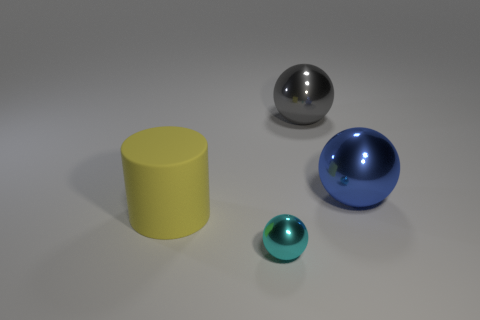Subtract all large balls. How many balls are left? 1 Add 2 large red metal balls. How many objects exist? 6 Subtract all cylinders. How many objects are left? 3 Subtract all purple balls. Subtract all blue cubes. How many balls are left? 3 Subtract 0 cyan cylinders. How many objects are left? 4 Subtract all large red shiny cylinders. Subtract all blue metallic balls. How many objects are left? 3 Add 2 large blue shiny objects. How many large blue shiny objects are left? 3 Add 4 gray things. How many gray things exist? 5 